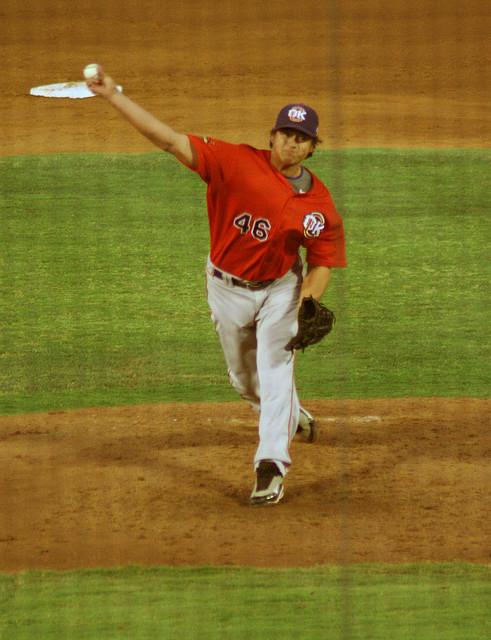What number is written on the shirt?
Concise answer only. 46. Is the man running?
Give a very brief answer. No. What sport is he playing?
Short answer required. Baseball. 